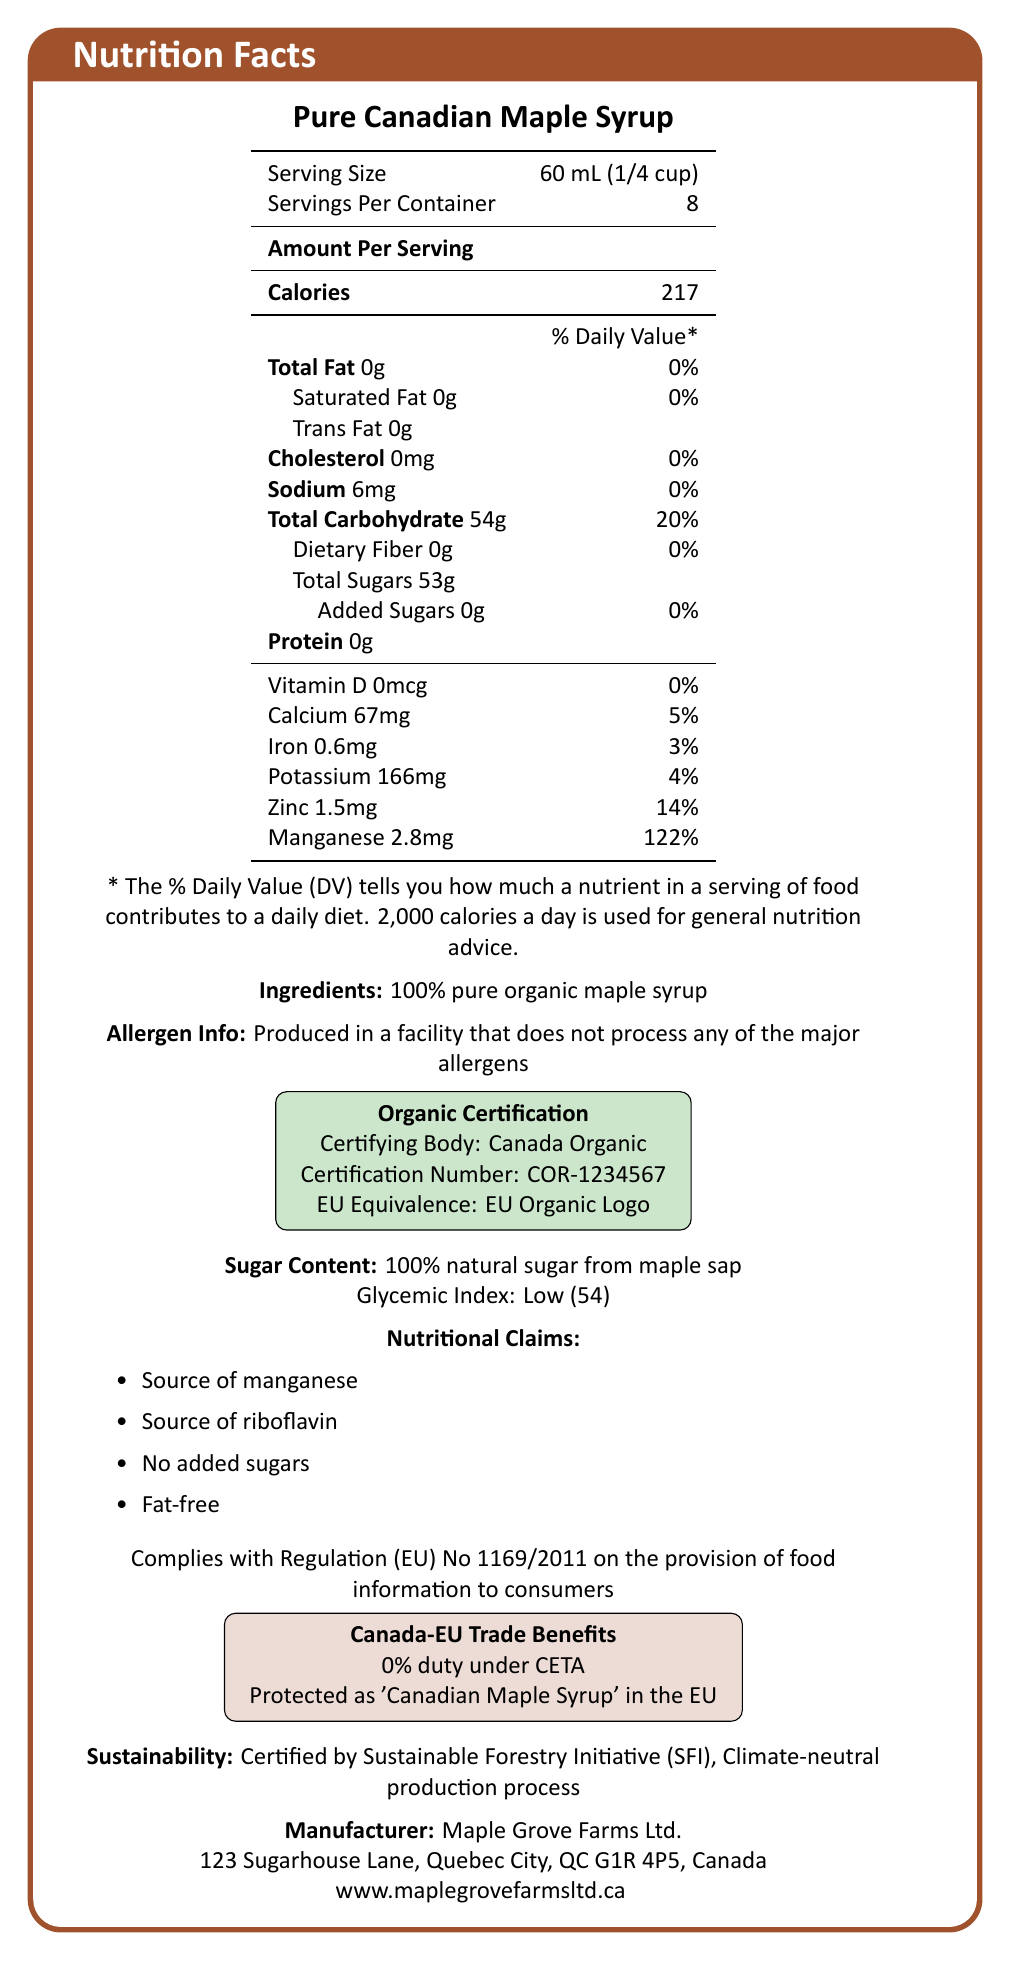what is the serving size? The serving size is provided at the top of the nutrition facts table.
Answer: 60 mL (1/4 cup) how many calories are there per serving? The calories per serving value is displayed as 217 under "Amount Per Serving".
Answer: 217 what is the total sugar content per serving? The total sugar content per serving is explicitly mentioned as 53g under "Total Carbohydrate".
Answer: 53 g what is the certifying body for the organic certification? The organic certification section lists "Certifying Body: Canada Organic".
Answer: Canada Organic what is the daily value percentage of manganese per serving? The daily value for manganese per serving is stated as 122% in the vitamins and minerals section.
Answer: 122% which of the following nutrients is present in the highest amount per serving?
A. Sodium
B. Potassium
C. Calcium Potassium is listed as 166 mg, which is higher than sodium (6 mg) and calcium (67 mg).
Answer: B. Potassium what is the glycemic index of the maple syrup? The glycemic index is mentioned as "Low (54)" under sugar content.
Answer: 54 (Low) does the syrup contain any added sugars? The nutrition facts label specifies "Added Sugars 0g" under total sugars.
Answer: No what is the iron content per serving? The iron content per serving is marked as 0.6 mg in the vitamins and minerals section.
Answer: 0.6 mg what is the origin country of the maple syrup? The export details section mentions the origin country as "Canada".
Answer: Canada is the maple syrup produced in a facility that processes major allergens? "Produced in a facility that does not process any of the major allergens" is clearly stated in the allergen info section.
Answer: No which of the following best describes the sustainability practices for this maple syrup?
A. Fair Trade Certified
B. Rainforest Alliance Certified
C. Certified by Sustainable Forestry Initiative (SFI) The sustainability info specifies that it is certified by the Sustainable Forestry Initiative (SFI).
Answer: C. Certified by Sustainable Forestry Initiative (SFI) summarize the main features of the Pure Canadian Maple Syrup. The document provides detailed nutritional information, mentions organic certification and sustainability practices, and outlines trade and regulatory compliance details.
Answer: Pure Canadian Maple Syrup is a 100% organic product certified by Canada Organic, with an EU equivalence. It has zero fat, cholesterol, and added sugars, and is a good source of manganese and riboflavin. It contains 53g of natural sugars per 60 mL serving and is produced sustainably. The product is imported into the EU under favorable trade conditions and complies with EU regulations. what is the exact percentage composition of glucose in the sugar composition? The document lists glucose as 0.3% in the sugar composition section under sugar content disclosure.
Answer: 0.3% what is the tariff duty for exporting this maple syrup to the EU under CETA? The Canada-EU trade benefits section states a 0% duty under CETA.
Answer: 0% what is the sugar source mentioned in the ingredients list? The ingredients list mentions that the syrup is made from "100% pure organic maple syrup".
Answer: 100% pure organic maple syrup which of the following nutritional claims is NOT mentioned for this syrup?
A. Source of manganese
B. Low sodium
C. Fat-free The document lists claims of "Source of manganese", "Source of riboflavin", "No added sugars", and "Fat-free", but not "Low sodium".
Answer: B. Low sodium does the maple syrup comply with EU food information regulations? The document states that it complies with Regulation (EU) No 1169/2011 on the provision of food information to consumers.
Answer: Yes what type of certification ensures the product's sustainability? The sustainability info states that the product is certified by the Sustainable Forestry Initiative (SFI).
Answer: Sustainable Forestry Initiative (SFI) how many servings are there per container? The servings per container are mentioned at the top of the nutrition facts table.
Answer: 8 is riboflavin listed in the vitamins and minerals section with a daily value percentage? Riboflavin is mentioned in the nutritional claims but it is not listed with a daily value percentage in the vitamins and minerals section.
Answer: No who is the EU importer of the maple syrup? The contact information lists EuroSweet Distribution GmbH as the EU importer.
Answer: EuroSweet Distribution GmbH what is the address of the manufacturer? The contact information section provides this address.
Answer: 123 Sugarhouse Lane, Quebec City, QC G1R 4P5, Canada 